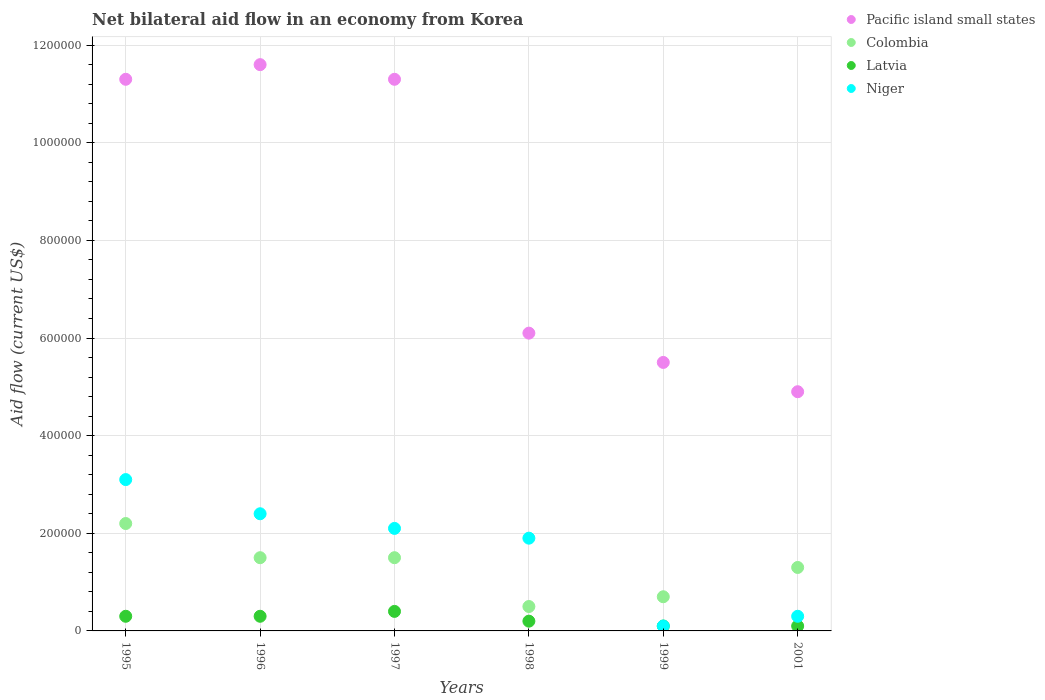How many different coloured dotlines are there?
Ensure brevity in your answer.  4. What is the net bilateral aid flow in Latvia in 1997?
Offer a very short reply. 4.00e+04. Across all years, what is the maximum net bilateral aid flow in Pacific island small states?
Give a very brief answer. 1.16e+06. In which year was the net bilateral aid flow in Niger maximum?
Provide a succinct answer. 1995. In which year was the net bilateral aid flow in Pacific island small states minimum?
Give a very brief answer. 2001. What is the total net bilateral aid flow in Niger in the graph?
Ensure brevity in your answer.  9.90e+05. What is the difference between the net bilateral aid flow in Niger in 1995 and that in 2001?
Offer a terse response. 2.80e+05. What is the difference between the net bilateral aid flow in Colombia in 1999 and the net bilateral aid flow in Pacific island small states in 2001?
Your answer should be compact. -4.20e+05. What is the average net bilateral aid flow in Niger per year?
Give a very brief answer. 1.65e+05. In the year 1996, what is the difference between the net bilateral aid flow in Latvia and net bilateral aid flow in Pacific island small states?
Provide a short and direct response. -1.13e+06. What is the ratio of the net bilateral aid flow in Niger in 1995 to that in 1996?
Your response must be concise. 1.29. Is the net bilateral aid flow in Latvia in 1995 less than that in 1999?
Keep it short and to the point. No. Is the difference between the net bilateral aid flow in Latvia in 1995 and 1998 greater than the difference between the net bilateral aid flow in Pacific island small states in 1995 and 1998?
Ensure brevity in your answer.  No. What is the difference between the highest and the lowest net bilateral aid flow in Colombia?
Ensure brevity in your answer.  1.70e+05. In how many years, is the net bilateral aid flow in Pacific island small states greater than the average net bilateral aid flow in Pacific island small states taken over all years?
Provide a short and direct response. 3. Is it the case that in every year, the sum of the net bilateral aid flow in Niger and net bilateral aid flow in Colombia  is greater than the sum of net bilateral aid flow in Pacific island small states and net bilateral aid flow in Latvia?
Provide a short and direct response. No. Is it the case that in every year, the sum of the net bilateral aid flow in Colombia and net bilateral aid flow in Niger  is greater than the net bilateral aid flow in Pacific island small states?
Keep it short and to the point. No. How many dotlines are there?
Your answer should be compact. 4. What is the difference between two consecutive major ticks on the Y-axis?
Your answer should be compact. 2.00e+05. Does the graph contain any zero values?
Your response must be concise. No. Does the graph contain grids?
Provide a succinct answer. Yes. Where does the legend appear in the graph?
Your answer should be compact. Top right. How many legend labels are there?
Provide a succinct answer. 4. What is the title of the graph?
Offer a terse response. Net bilateral aid flow in an economy from Korea. What is the Aid flow (current US$) in Pacific island small states in 1995?
Give a very brief answer. 1.13e+06. What is the Aid flow (current US$) in Latvia in 1995?
Give a very brief answer. 3.00e+04. What is the Aid flow (current US$) in Pacific island small states in 1996?
Make the answer very short. 1.16e+06. What is the Aid flow (current US$) of Latvia in 1996?
Keep it short and to the point. 3.00e+04. What is the Aid flow (current US$) in Niger in 1996?
Your answer should be compact. 2.40e+05. What is the Aid flow (current US$) in Pacific island small states in 1997?
Offer a very short reply. 1.13e+06. What is the Aid flow (current US$) of Colombia in 1997?
Make the answer very short. 1.50e+05. What is the Aid flow (current US$) of Latvia in 1997?
Offer a terse response. 4.00e+04. What is the Aid flow (current US$) of Colombia in 1998?
Keep it short and to the point. 5.00e+04. What is the Aid flow (current US$) of Niger in 1998?
Give a very brief answer. 1.90e+05. What is the Aid flow (current US$) in Pacific island small states in 1999?
Offer a terse response. 5.50e+05. What is the Aid flow (current US$) of Colombia in 1999?
Your answer should be very brief. 7.00e+04. What is the Aid flow (current US$) in Latvia in 1999?
Give a very brief answer. 10000. What is the Aid flow (current US$) in Niger in 2001?
Your answer should be compact. 3.00e+04. Across all years, what is the maximum Aid flow (current US$) of Pacific island small states?
Your answer should be compact. 1.16e+06. What is the total Aid flow (current US$) in Pacific island small states in the graph?
Provide a succinct answer. 5.07e+06. What is the total Aid flow (current US$) of Colombia in the graph?
Your answer should be very brief. 7.70e+05. What is the total Aid flow (current US$) in Niger in the graph?
Your response must be concise. 9.90e+05. What is the difference between the Aid flow (current US$) of Pacific island small states in 1995 and that in 1996?
Your response must be concise. -3.00e+04. What is the difference between the Aid flow (current US$) of Colombia in 1995 and that in 1996?
Give a very brief answer. 7.00e+04. What is the difference between the Aid flow (current US$) in Latvia in 1995 and that in 1996?
Ensure brevity in your answer.  0. What is the difference between the Aid flow (current US$) of Niger in 1995 and that in 1996?
Your answer should be compact. 7.00e+04. What is the difference between the Aid flow (current US$) in Colombia in 1995 and that in 1997?
Your answer should be compact. 7.00e+04. What is the difference between the Aid flow (current US$) of Pacific island small states in 1995 and that in 1998?
Offer a very short reply. 5.20e+05. What is the difference between the Aid flow (current US$) of Latvia in 1995 and that in 1998?
Offer a terse response. 10000. What is the difference between the Aid flow (current US$) in Pacific island small states in 1995 and that in 1999?
Give a very brief answer. 5.80e+05. What is the difference between the Aid flow (current US$) in Colombia in 1995 and that in 1999?
Offer a very short reply. 1.50e+05. What is the difference between the Aid flow (current US$) of Latvia in 1995 and that in 1999?
Provide a succinct answer. 2.00e+04. What is the difference between the Aid flow (current US$) of Niger in 1995 and that in 1999?
Provide a succinct answer. 3.00e+05. What is the difference between the Aid flow (current US$) of Pacific island small states in 1995 and that in 2001?
Provide a succinct answer. 6.40e+05. What is the difference between the Aid flow (current US$) of Colombia in 1995 and that in 2001?
Provide a short and direct response. 9.00e+04. What is the difference between the Aid flow (current US$) in Niger in 1995 and that in 2001?
Your answer should be very brief. 2.80e+05. What is the difference between the Aid flow (current US$) in Pacific island small states in 1996 and that in 1997?
Keep it short and to the point. 3.00e+04. What is the difference between the Aid flow (current US$) in Pacific island small states in 1996 and that in 1998?
Provide a short and direct response. 5.50e+05. What is the difference between the Aid flow (current US$) in Pacific island small states in 1996 and that in 1999?
Ensure brevity in your answer.  6.10e+05. What is the difference between the Aid flow (current US$) of Colombia in 1996 and that in 1999?
Offer a terse response. 8.00e+04. What is the difference between the Aid flow (current US$) of Latvia in 1996 and that in 1999?
Provide a short and direct response. 2.00e+04. What is the difference between the Aid flow (current US$) of Niger in 1996 and that in 1999?
Offer a very short reply. 2.30e+05. What is the difference between the Aid flow (current US$) of Pacific island small states in 1996 and that in 2001?
Make the answer very short. 6.70e+05. What is the difference between the Aid flow (current US$) in Latvia in 1996 and that in 2001?
Give a very brief answer. 2.00e+04. What is the difference between the Aid flow (current US$) in Niger in 1996 and that in 2001?
Keep it short and to the point. 2.10e+05. What is the difference between the Aid flow (current US$) of Pacific island small states in 1997 and that in 1998?
Offer a very short reply. 5.20e+05. What is the difference between the Aid flow (current US$) in Niger in 1997 and that in 1998?
Provide a short and direct response. 2.00e+04. What is the difference between the Aid flow (current US$) in Pacific island small states in 1997 and that in 1999?
Provide a succinct answer. 5.80e+05. What is the difference between the Aid flow (current US$) in Colombia in 1997 and that in 1999?
Provide a short and direct response. 8.00e+04. What is the difference between the Aid flow (current US$) in Pacific island small states in 1997 and that in 2001?
Your answer should be compact. 6.40e+05. What is the difference between the Aid flow (current US$) in Latvia in 1997 and that in 2001?
Your answer should be compact. 3.00e+04. What is the difference between the Aid flow (current US$) in Colombia in 1998 and that in 1999?
Offer a very short reply. -2.00e+04. What is the difference between the Aid flow (current US$) of Latvia in 1998 and that in 1999?
Provide a short and direct response. 10000. What is the difference between the Aid flow (current US$) of Pacific island small states in 1998 and that in 2001?
Provide a succinct answer. 1.20e+05. What is the difference between the Aid flow (current US$) of Colombia in 1998 and that in 2001?
Provide a succinct answer. -8.00e+04. What is the difference between the Aid flow (current US$) in Latvia in 1998 and that in 2001?
Your answer should be very brief. 10000. What is the difference between the Aid flow (current US$) in Niger in 1998 and that in 2001?
Your response must be concise. 1.60e+05. What is the difference between the Aid flow (current US$) in Colombia in 1999 and that in 2001?
Ensure brevity in your answer.  -6.00e+04. What is the difference between the Aid flow (current US$) in Latvia in 1999 and that in 2001?
Your response must be concise. 0. What is the difference between the Aid flow (current US$) in Pacific island small states in 1995 and the Aid flow (current US$) in Colombia in 1996?
Provide a short and direct response. 9.80e+05. What is the difference between the Aid flow (current US$) in Pacific island small states in 1995 and the Aid flow (current US$) in Latvia in 1996?
Offer a very short reply. 1.10e+06. What is the difference between the Aid flow (current US$) of Pacific island small states in 1995 and the Aid flow (current US$) of Niger in 1996?
Provide a succinct answer. 8.90e+05. What is the difference between the Aid flow (current US$) of Colombia in 1995 and the Aid flow (current US$) of Latvia in 1996?
Your response must be concise. 1.90e+05. What is the difference between the Aid flow (current US$) of Latvia in 1995 and the Aid flow (current US$) of Niger in 1996?
Offer a terse response. -2.10e+05. What is the difference between the Aid flow (current US$) in Pacific island small states in 1995 and the Aid flow (current US$) in Colombia in 1997?
Make the answer very short. 9.80e+05. What is the difference between the Aid flow (current US$) of Pacific island small states in 1995 and the Aid flow (current US$) of Latvia in 1997?
Keep it short and to the point. 1.09e+06. What is the difference between the Aid flow (current US$) of Pacific island small states in 1995 and the Aid flow (current US$) of Niger in 1997?
Offer a very short reply. 9.20e+05. What is the difference between the Aid flow (current US$) in Colombia in 1995 and the Aid flow (current US$) in Latvia in 1997?
Provide a succinct answer. 1.80e+05. What is the difference between the Aid flow (current US$) in Colombia in 1995 and the Aid flow (current US$) in Niger in 1997?
Give a very brief answer. 10000. What is the difference between the Aid flow (current US$) of Pacific island small states in 1995 and the Aid flow (current US$) of Colombia in 1998?
Ensure brevity in your answer.  1.08e+06. What is the difference between the Aid flow (current US$) of Pacific island small states in 1995 and the Aid flow (current US$) of Latvia in 1998?
Your response must be concise. 1.11e+06. What is the difference between the Aid flow (current US$) in Pacific island small states in 1995 and the Aid flow (current US$) in Niger in 1998?
Your response must be concise. 9.40e+05. What is the difference between the Aid flow (current US$) of Pacific island small states in 1995 and the Aid flow (current US$) of Colombia in 1999?
Keep it short and to the point. 1.06e+06. What is the difference between the Aid flow (current US$) of Pacific island small states in 1995 and the Aid flow (current US$) of Latvia in 1999?
Offer a terse response. 1.12e+06. What is the difference between the Aid flow (current US$) of Pacific island small states in 1995 and the Aid flow (current US$) of Niger in 1999?
Make the answer very short. 1.12e+06. What is the difference between the Aid flow (current US$) in Latvia in 1995 and the Aid flow (current US$) in Niger in 1999?
Your response must be concise. 2.00e+04. What is the difference between the Aid flow (current US$) in Pacific island small states in 1995 and the Aid flow (current US$) in Colombia in 2001?
Offer a very short reply. 1.00e+06. What is the difference between the Aid flow (current US$) of Pacific island small states in 1995 and the Aid flow (current US$) of Latvia in 2001?
Make the answer very short. 1.12e+06. What is the difference between the Aid flow (current US$) of Pacific island small states in 1995 and the Aid flow (current US$) of Niger in 2001?
Ensure brevity in your answer.  1.10e+06. What is the difference between the Aid flow (current US$) of Colombia in 1995 and the Aid flow (current US$) of Niger in 2001?
Provide a short and direct response. 1.90e+05. What is the difference between the Aid flow (current US$) of Latvia in 1995 and the Aid flow (current US$) of Niger in 2001?
Keep it short and to the point. 0. What is the difference between the Aid flow (current US$) of Pacific island small states in 1996 and the Aid flow (current US$) of Colombia in 1997?
Your response must be concise. 1.01e+06. What is the difference between the Aid flow (current US$) in Pacific island small states in 1996 and the Aid flow (current US$) in Latvia in 1997?
Provide a short and direct response. 1.12e+06. What is the difference between the Aid flow (current US$) of Pacific island small states in 1996 and the Aid flow (current US$) of Niger in 1997?
Your answer should be very brief. 9.50e+05. What is the difference between the Aid flow (current US$) of Colombia in 1996 and the Aid flow (current US$) of Niger in 1997?
Give a very brief answer. -6.00e+04. What is the difference between the Aid flow (current US$) of Pacific island small states in 1996 and the Aid flow (current US$) of Colombia in 1998?
Ensure brevity in your answer.  1.11e+06. What is the difference between the Aid flow (current US$) in Pacific island small states in 1996 and the Aid flow (current US$) in Latvia in 1998?
Your answer should be very brief. 1.14e+06. What is the difference between the Aid flow (current US$) of Pacific island small states in 1996 and the Aid flow (current US$) of Niger in 1998?
Keep it short and to the point. 9.70e+05. What is the difference between the Aid flow (current US$) in Colombia in 1996 and the Aid flow (current US$) in Niger in 1998?
Provide a succinct answer. -4.00e+04. What is the difference between the Aid flow (current US$) in Pacific island small states in 1996 and the Aid flow (current US$) in Colombia in 1999?
Give a very brief answer. 1.09e+06. What is the difference between the Aid flow (current US$) in Pacific island small states in 1996 and the Aid flow (current US$) in Latvia in 1999?
Give a very brief answer. 1.15e+06. What is the difference between the Aid flow (current US$) of Pacific island small states in 1996 and the Aid flow (current US$) of Niger in 1999?
Provide a succinct answer. 1.15e+06. What is the difference between the Aid flow (current US$) in Colombia in 1996 and the Aid flow (current US$) in Latvia in 1999?
Give a very brief answer. 1.40e+05. What is the difference between the Aid flow (current US$) in Pacific island small states in 1996 and the Aid flow (current US$) in Colombia in 2001?
Your answer should be very brief. 1.03e+06. What is the difference between the Aid flow (current US$) in Pacific island small states in 1996 and the Aid flow (current US$) in Latvia in 2001?
Offer a very short reply. 1.15e+06. What is the difference between the Aid flow (current US$) in Pacific island small states in 1996 and the Aid flow (current US$) in Niger in 2001?
Your answer should be compact. 1.13e+06. What is the difference between the Aid flow (current US$) in Latvia in 1996 and the Aid flow (current US$) in Niger in 2001?
Make the answer very short. 0. What is the difference between the Aid flow (current US$) in Pacific island small states in 1997 and the Aid flow (current US$) in Colombia in 1998?
Provide a succinct answer. 1.08e+06. What is the difference between the Aid flow (current US$) of Pacific island small states in 1997 and the Aid flow (current US$) of Latvia in 1998?
Ensure brevity in your answer.  1.11e+06. What is the difference between the Aid flow (current US$) of Pacific island small states in 1997 and the Aid flow (current US$) of Niger in 1998?
Offer a very short reply. 9.40e+05. What is the difference between the Aid flow (current US$) in Pacific island small states in 1997 and the Aid flow (current US$) in Colombia in 1999?
Provide a succinct answer. 1.06e+06. What is the difference between the Aid flow (current US$) of Pacific island small states in 1997 and the Aid flow (current US$) of Latvia in 1999?
Your response must be concise. 1.12e+06. What is the difference between the Aid flow (current US$) of Pacific island small states in 1997 and the Aid flow (current US$) of Niger in 1999?
Your response must be concise. 1.12e+06. What is the difference between the Aid flow (current US$) of Colombia in 1997 and the Aid flow (current US$) of Latvia in 1999?
Offer a terse response. 1.40e+05. What is the difference between the Aid flow (current US$) in Latvia in 1997 and the Aid flow (current US$) in Niger in 1999?
Your answer should be very brief. 3.00e+04. What is the difference between the Aid flow (current US$) in Pacific island small states in 1997 and the Aid flow (current US$) in Latvia in 2001?
Ensure brevity in your answer.  1.12e+06. What is the difference between the Aid flow (current US$) in Pacific island small states in 1997 and the Aid flow (current US$) in Niger in 2001?
Your response must be concise. 1.10e+06. What is the difference between the Aid flow (current US$) in Pacific island small states in 1998 and the Aid flow (current US$) in Colombia in 1999?
Provide a short and direct response. 5.40e+05. What is the difference between the Aid flow (current US$) of Pacific island small states in 1998 and the Aid flow (current US$) of Niger in 1999?
Offer a very short reply. 6.00e+05. What is the difference between the Aid flow (current US$) of Pacific island small states in 1998 and the Aid flow (current US$) of Colombia in 2001?
Keep it short and to the point. 4.80e+05. What is the difference between the Aid flow (current US$) of Pacific island small states in 1998 and the Aid flow (current US$) of Latvia in 2001?
Your answer should be compact. 6.00e+05. What is the difference between the Aid flow (current US$) of Pacific island small states in 1998 and the Aid flow (current US$) of Niger in 2001?
Provide a succinct answer. 5.80e+05. What is the difference between the Aid flow (current US$) of Colombia in 1998 and the Aid flow (current US$) of Latvia in 2001?
Provide a short and direct response. 4.00e+04. What is the difference between the Aid flow (current US$) in Pacific island small states in 1999 and the Aid flow (current US$) in Colombia in 2001?
Offer a terse response. 4.20e+05. What is the difference between the Aid flow (current US$) in Pacific island small states in 1999 and the Aid flow (current US$) in Latvia in 2001?
Make the answer very short. 5.40e+05. What is the difference between the Aid flow (current US$) of Pacific island small states in 1999 and the Aid flow (current US$) of Niger in 2001?
Your answer should be very brief. 5.20e+05. What is the difference between the Aid flow (current US$) in Colombia in 1999 and the Aid flow (current US$) in Latvia in 2001?
Provide a succinct answer. 6.00e+04. What is the difference between the Aid flow (current US$) of Colombia in 1999 and the Aid flow (current US$) of Niger in 2001?
Provide a succinct answer. 4.00e+04. What is the difference between the Aid flow (current US$) in Latvia in 1999 and the Aid flow (current US$) in Niger in 2001?
Provide a succinct answer. -2.00e+04. What is the average Aid flow (current US$) in Pacific island small states per year?
Provide a short and direct response. 8.45e+05. What is the average Aid flow (current US$) in Colombia per year?
Provide a succinct answer. 1.28e+05. What is the average Aid flow (current US$) in Latvia per year?
Offer a very short reply. 2.33e+04. What is the average Aid flow (current US$) in Niger per year?
Offer a terse response. 1.65e+05. In the year 1995, what is the difference between the Aid flow (current US$) of Pacific island small states and Aid flow (current US$) of Colombia?
Your answer should be very brief. 9.10e+05. In the year 1995, what is the difference between the Aid flow (current US$) in Pacific island small states and Aid flow (current US$) in Latvia?
Offer a very short reply. 1.10e+06. In the year 1995, what is the difference between the Aid flow (current US$) of Pacific island small states and Aid flow (current US$) of Niger?
Your response must be concise. 8.20e+05. In the year 1995, what is the difference between the Aid flow (current US$) in Colombia and Aid flow (current US$) in Latvia?
Ensure brevity in your answer.  1.90e+05. In the year 1995, what is the difference between the Aid flow (current US$) in Colombia and Aid flow (current US$) in Niger?
Provide a short and direct response. -9.00e+04. In the year 1995, what is the difference between the Aid flow (current US$) in Latvia and Aid flow (current US$) in Niger?
Provide a succinct answer. -2.80e+05. In the year 1996, what is the difference between the Aid flow (current US$) of Pacific island small states and Aid flow (current US$) of Colombia?
Provide a succinct answer. 1.01e+06. In the year 1996, what is the difference between the Aid flow (current US$) of Pacific island small states and Aid flow (current US$) of Latvia?
Give a very brief answer. 1.13e+06. In the year 1996, what is the difference between the Aid flow (current US$) in Pacific island small states and Aid flow (current US$) in Niger?
Offer a very short reply. 9.20e+05. In the year 1996, what is the difference between the Aid flow (current US$) of Colombia and Aid flow (current US$) of Latvia?
Provide a succinct answer. 1.20e+05. In the year 1996, what is the difference between the Aid flow (current US$) in Colombia and Aid flow (current US$) in Niger?
Your response must be concise. -9.00e+04. In the year 1997, what is the difference between the Aid flow (current US$) in Pacific island small states and Aid flow (current US$) in Colombia?
Your response must be concise. 9.80e+05. In the year 1997, what is the difference between the Aid flow (current US$) of Pacific island small states and Aid flow (current US$) of Latvia?
Provide a short and direct response. 1.09e+06. In the year 1997, what is the difference between the Aid flow (current US$) in Pacific island small states and Aid flow (current US$) in Niger?
Offer a terse response. 9.20e+05. In the year 1997, what is the difference between the Aid flow (current US$) in Latvia and Aid flow (current US$) in Niger?
Offer a very short reply. -1.70e+05. In the year 1998, what is the difference between the Aid flow (current US$) of Pacific island small states and Aid flow (current US$) of Colombia?
Your answer should be compact. 5.60e+05. In the year 1998, what is the difference between the Aid flow (current US$) of Pacific island small states and Aid flow (current US$) of Latvia?
Ensure brevity in your answer.  5.90e+05. In the year 1998, what is the difference between the Aid flow (current US$) in Latvia and Aid flow (current US$) in Niger?
Give a very brief answer. -1.70e+05. In the year 1999, what is the difference between the Aid flow (current US$) of Pacific island small states and Aid flow (current US$) of Colombia?
Make the answer very short. 4.80e+05. In the year 1999, what is the difference between the Aid flow (current US$) in Pacific island small states and Aid flow (current US$) in Latvia?
Provide a short and direct response. 5.40e+05. In the year 1999, what is the difference between the Aid flow (current US$) of Pacific island small states and Aid flow (current US$) of Niger?
Offer a terse response. 5.40e+05. In the year 1999, what is the difference between the Aid flow (current US$) of Colombia and Aid flow (current US$) of Latvia?
Give a very brief answer. 6.00e+04. In the year 1999, what is the difference between the Aid flow (current US$) of Latvia and Aid flow (current US$) of Niger?
Ensure brevity in your answer.  0. In the year 2001, what is the difference between the Aid flow (current US$) of Pacific island small states and Aid flow (current US$) of Colombia?
Your answer should be very brief. 3.60e+05. In the year 2001, what is the difference between the Aid flow (current US$) in Pacific island small states and Aid flow (current US$) in Niger?
Provide a succinct answer. 4.60e+05. In the year 2001, what is the difference between the Aid flow (current US$) of Colombia and Aid flow (current US$) of Latvia?
Keep it short and to the point. 1.20e+05. In the year 2001, what is the difference between the Aid flow (current US$) of Latvia and Aid flow (current US$) of Niger?
Provide a short and direct response. -2.00e+04. What is the ratio of the Aid flow (current US$) of Pacific island small states in 1995 to that in 1996?
Offer a terse response. 0.97. What is the ratio of the Aid flow (current US$) in Colombia in 1995 to that in 1996?
Provide a short and direct response. 1.47. What is the ratio of the Aid flow (current US$) of Latvia in 1995 to that in 1996?
Keep it short and to the point. 1. What is the ratio of the Aid flow (current US$) of Niger in 1995 to that in 1996?
Keep it short and to the point. 1.29. What is the ratio of the Aid flow (current US$) in Colombia in 1995 to that in 1997?
Ensure brevity in your answer.  1.47. What is the ratio of the Aid flow (current US$) in Latvia in 1995 to that in 1997?
Ensure brevity in your answer.  0.75. What is the ratio of the Aid flow (current US$) of Niger in 1995 to that in 1997?
Offer a very short reply. 1.48. What is the ratio of the Aid flow (current US$) in Pacific island small states in 1995 to that in 1998?
Provide a short and direct response. 1.85. What is the ratio of the Aid flow (current US$) of Niger in 1995 to that in 1998?
Provide a short and direct response. 1.63. What is the ratio of the Aid flow (current US$) of Pacific island small states in 1995 to that in 1999?
Provide a succinct answer. 2.05. What is the ratio of the Aid flow (current US$) in Colombia in 1995 to that in 1999?
Ensure brevity in your answer.  3.14. What is the ratio of the Aid flow (current US$) in Pacific island small states in 1995 to that in 2001?
Your response must be concise. 2.31. What is the ratio of the Aid flow (current US$) in Colombia in 1995 to that in 2001?
Keep it short and to the point. 1.69. What is the ratio of the Aid flow (current US$) of Latvia in 1995 to that in 2001?
Provide a succinct answer. 3. What is the ratio of the Aid flow (current US$) in Niger in 1995 to that in 2001?
Keep it short and to the point. 10.33. What is the ratio of the Aid flow (current US$) of Pacific island small states in 1996 to that in 1997?
Your answer should be compact. 1.03. What is the ratio of the Aid flow (current US$) in Niger in 1996 to that in 1997?
Make the answer very short. 1.14. What is the ratio of the Aid flow (current US$) of Pacific island small states in 1996 to that in 1998?
Offer a terse response. 1.9. What is the ratio of the Aid flow (current US$) in Colombia in 1996 to that in 1998?
Ensure brevity in your answer.  3. What is the ratio of the Aid flow (current US$) in Latvia in 1996 to that in 1998?
Give a very brief answer. 1.5. What is the ratio of the Aid flow (current US$) of Niger in 1996 to that in 1998?
Offer a very short reply. 1.26. What is the ratio of the Aid flow (current US$) of Pacific island small states in 1996 to that in 1999?
Give a very brief answer. 2.11. What is the ratio of the Aid flow (current US$) in Colombia in 1996 to that in 1999?
Ensure brevity in your answer.  2.14. What is the ratio of the Aid flow (current US$) of Latvia in 1996 to that in 1999?
Provide a succinct answer. 3. What is the ratio of the Aid flow (current US$) in Niger in 1996 to that in 1999?
Provide a short and direct response. 24. What is the ratio of the Aid flow (current US$) in Pacific island small states in 1996 to that in 2001?
Provide a succinct answer. 2.37. What is the ratio of the Aid flow (current US$) of Colombia in 1996 to that in 2001?
Keep it short and to the point. 1.15. What is the ratio of the Aid flow (current US$) of Latvia in 1996 to that in 2001?
Provide a succinct answer. 3. What is the ratio of the Aid flow (current US$) of Niger in 1996 to that in 2001?
Offer a terse response. 8. What is the ratio of the Aid flow (current US$) of Pacific island small states in 1997 to that in 1998?
Your response must be concise. 1.85. What is the ratio of the Aid flow (current US$) of Niger in 1997 to that in 1998?
Your response must be concise. 1.11. What is the ratio of the Aid flow (current US$) of Pacific island small states in 1997 to that in 1999?
Your answer should be very brief. 2.05. What is the ratio of the Aid flow (current US$) of Colombia in 1997 to that in 1999?
Offer a terse response. 2.14. What is the ratio of the Aid flow (current US$) in Niger in 1997 to that in 1999?
Make the answer very short. 21. What is the ratio of the Aid flow (current US$) of Pacific island small states in 1997 to that in 2001?
Provide a succinct answer. 2.31. What is the ratio of the Aid flow (current US$) in Colombia in 1997 to that in 2001?
Keep it short and to the point. 1.15. What is the ratio of the Aid flow (current US$) in Pacific island small states in 1998 to that in 1999?
Ensure brevity in your answer.  1.11. What is the ratio of the Aid flow (current US$) of Latvia in 1998 to that in 1999?
Keep it short and to the point. 2. What is the ratio of the Aid flow (current US$) in Pacific island small states in 1998 to that in 2001?
Give a very brief answer. 1.24. What is the ratio of the Aid flow (current US$) of Colombia in 1998 to that in 2001?
Give a very brief answer. 0.38. What is the ratio of the Aid flow (current US$) in Niger in 1998 to that in 2001?
Your response must be concise. 6.33. What is the ratio of the Aid flow (current US$) of Pacific island small states in 1999 to that in 2001?
Your answer should be very brief. 1.12. What is the ratio of the Aid flow (current US$) in Colombia in 1999 to that in 2001?
Provide a succinct answer. 0.54. What is the difference between the highest and the second highest Aid flow (current US$) of Pacific island small states?
Offer a terse response. 3.00e+04. What is the difference between the highest and the second highest Aid flow (current US$) of Niger?
Your response must be concise. 7.00e+04. What is the difference between the highest and the lowest Aid flow (current US$) in Pacific island small states?
Your answer should be compact. 6.70e+05. What is the difference between the highest and the lowest Aid flow (current US$) in Colombia?
Provide a succinct answer. 1.70e+05. What is the difference between the highest and the lowest Aid flow (current US$) of Niger?
Offer a very short reply. 3.00e+05. 